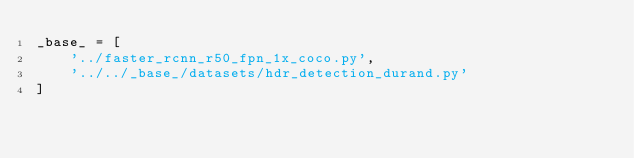<code> <loc_0><loc_0><loc_500><loc_500><_Python_>_base_ = [
    '../faster_rcnn_r50_fpn_1x_coco.py',
    '../../_base_/datasets/hdr_detection_durand.py'
]
</code> 